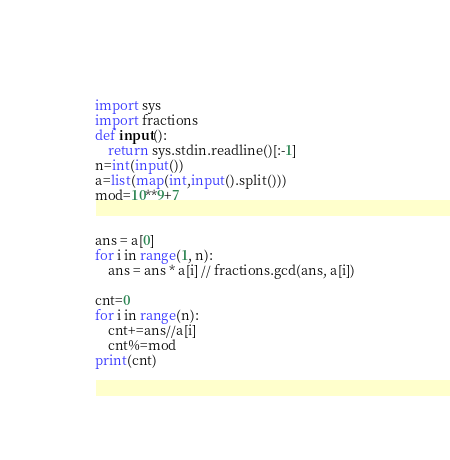Convert code to text. <code><loc_0><loc_0><loc_500><loc_500><_Python_>import sys
import fractions
def input():
    return sys.stdin.readline()[:-1]
n=int(input())
a=list(map(int,input().split()))
mod=10**9+7


ans = a[0]
for i in range(1, n):
    ans = ans * a[i] // fractions.gcd(ans, a[i])

cnt=0
for i in range(n):
    cnt+=ans//a[i]
    cnt%=mod
print(cnt)
</code> 